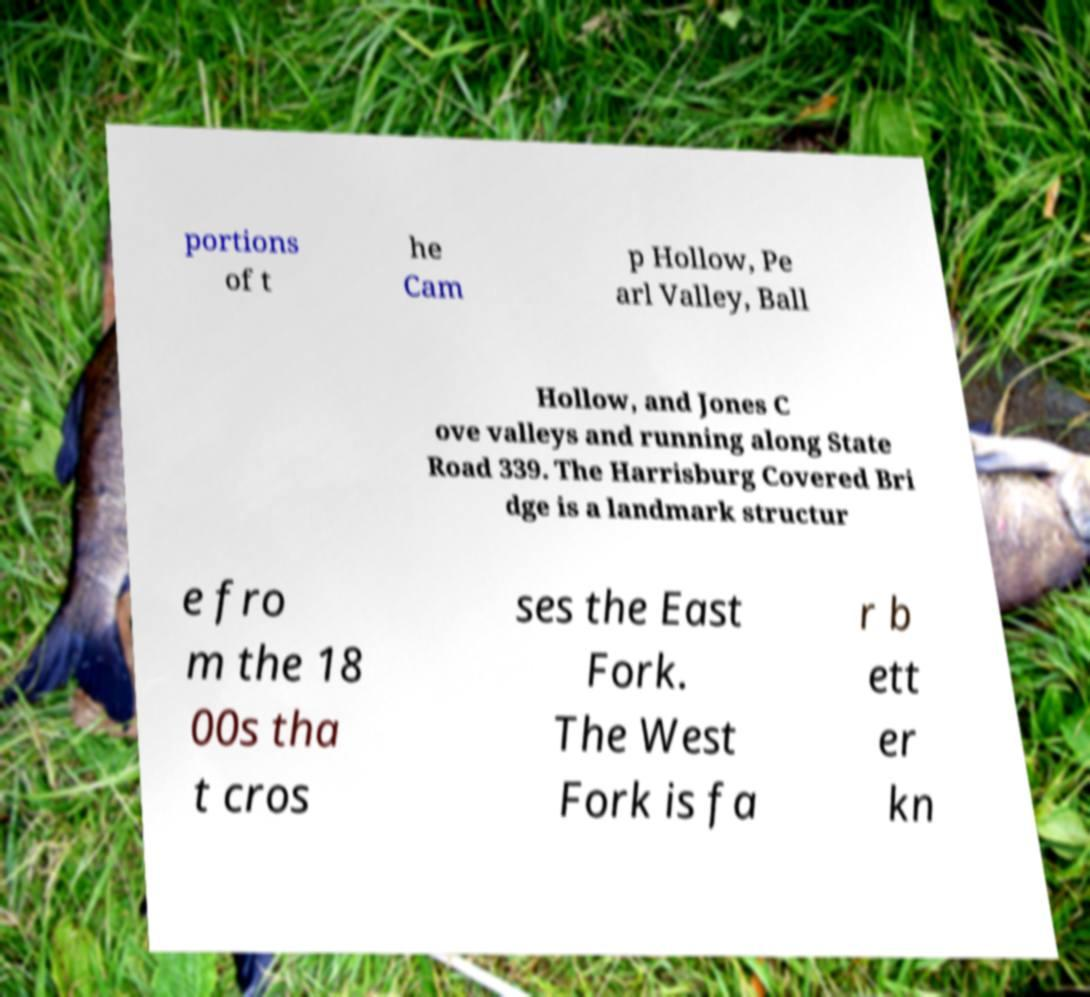There's text embedded in this image that I need extracted. Can you transcribe it verbatim? portions of t he Cam p Hollow, Pe arl Valley, Ball Hollow, and Jones C ove valleys and running along State Road 339. The Harrisburg Covered Bri dge is a landmark structur e fro m the 18 00s tha t cros ses the East Fork. The West Fork is fa r b ett er kn 